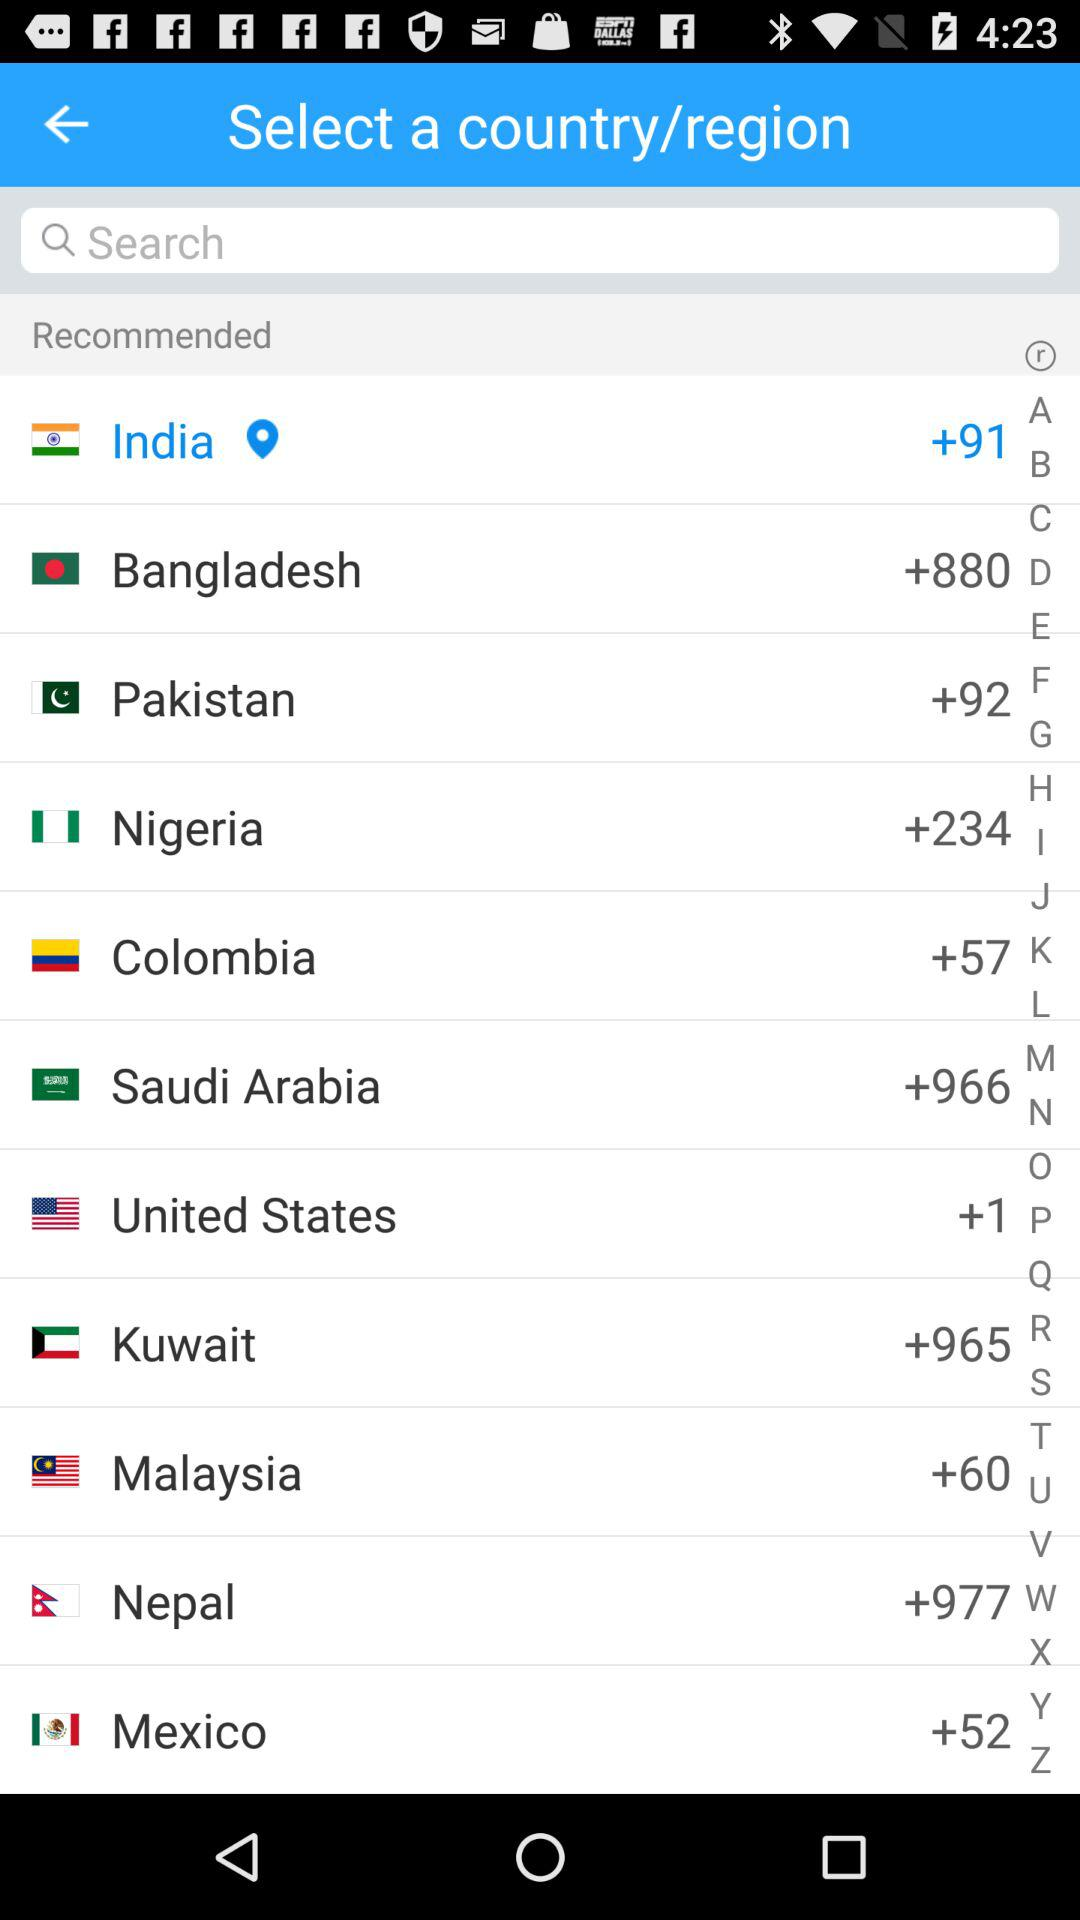Which county has been chosen? The country that has been chosen is India. 